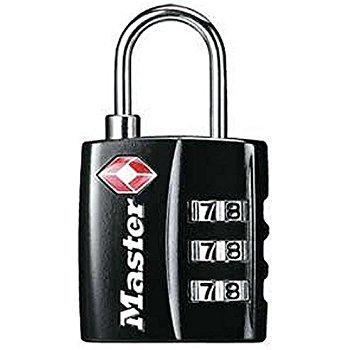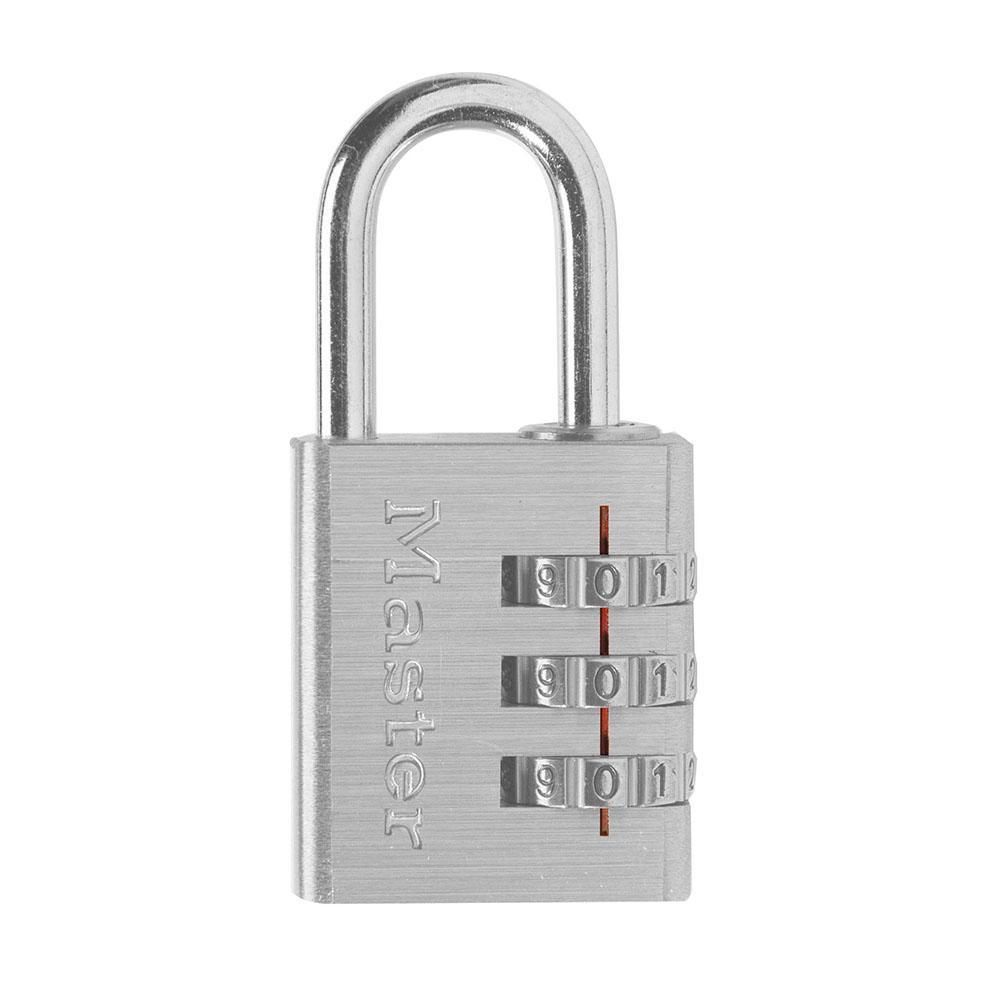The first image is the image on the left, the second image is the image on the right. Given the left and right images, does the statement "All combination locks have black bodies with silver lock loops at the top, and black numbers on sliding silver number belts." hold true? Answer yes or no. No. The first image is the image on the left, the second image is the image on the right. For the images displayed, is the sentence "All of the locks have black bodies with a metal ring." factually correct? Answer yes or no. No. 